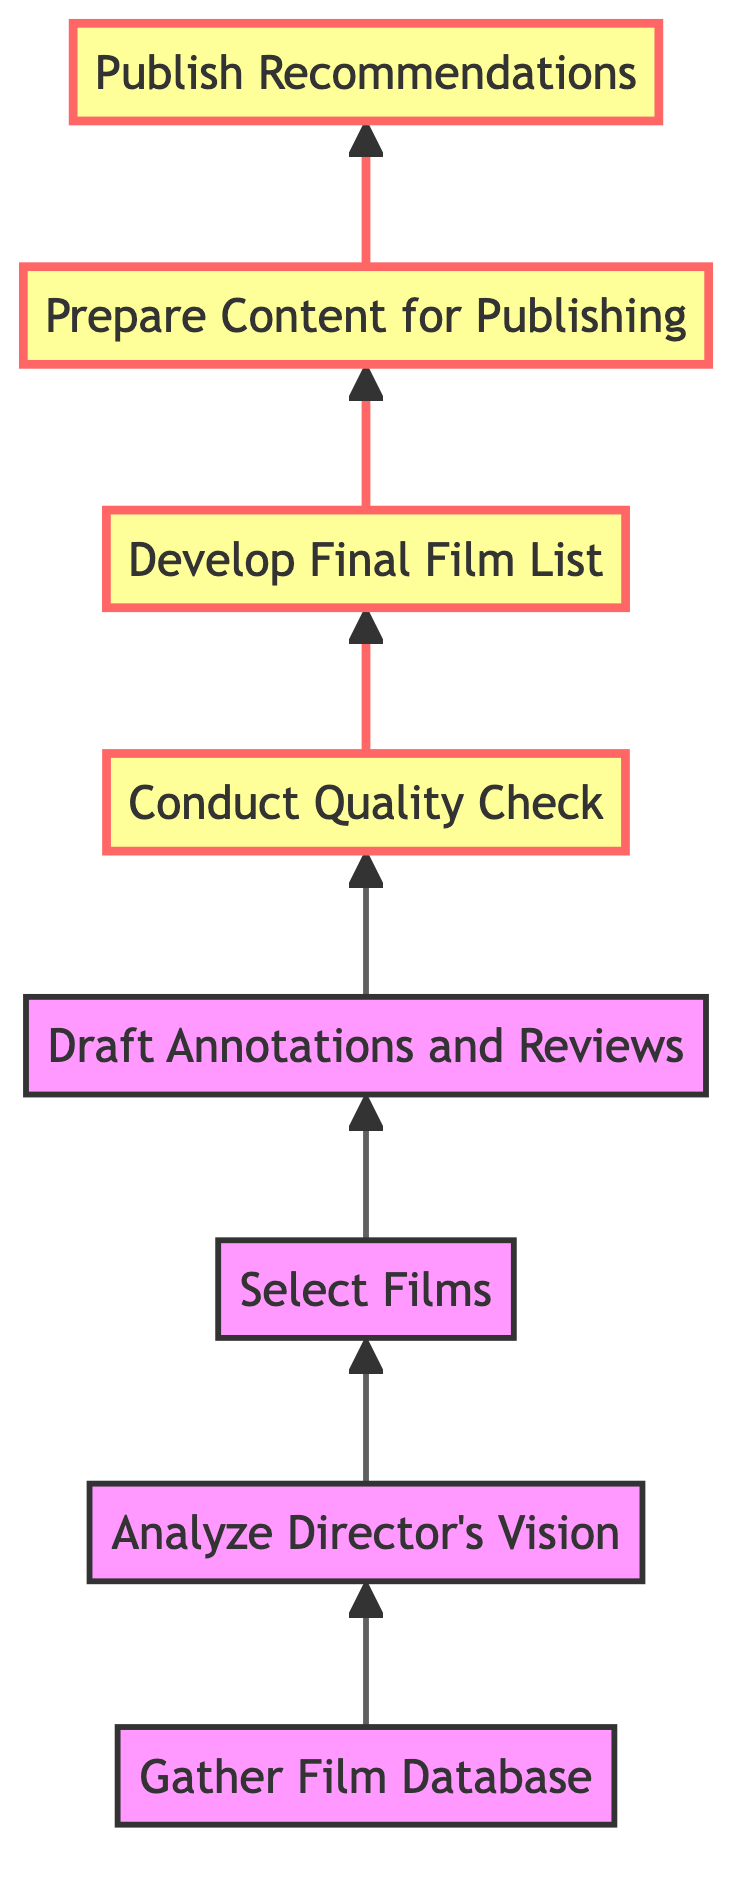What is the first step in the workflow? The first step in the workflow is indicated at the bottom of the diagram. It is "Gather Film Database."
Answer: Gather Film Database How many total steps are in the workflow? By counting the number of unique steps listed in the diagram, there are eight steps total.
Answer: Eight What step follows "Select Films"? Following "Select Films," the next step in the flowchart is "Draft Annotations and Reviews."
Answer: Draft Annotations and Reviews Which step involves reviewing selected films? The step that involves reviewing selected films for accuracy and cohesion is "Conduct Quality Check."
Answer: Conduct Quality Check What is the last step in the workflow? The last step, as indicated at the top of the diagram, is "Publish Recommendations."
Answer: Publish Recommendations Which steps are highlighted in the diagram? In the diagram, the highlighted steps are "Draft Annotations and Reviews," "Conduct Quality Check," "Develop Final Film List," and "Prepare Content for Publishing."
Answer: Draft Annotations and Reviews, Conduct Quality Check, Develop Final Film List, Prepare Content for Publishing Which step is directly dependent on "Analyze Director's Vision"? The step that directly follows "Analyze Director's Vision" and is therefore dependent on it is "Select Films."
Answer: Select Films How many steps are highlighted in total? There are four steps highlighted in the diagram.
Answer: Four What is the relationship between "Develop Final Film List" and "Prepare Content for Publishing"? The relationship is that "Develop Final Film List" leads directly into "Prepare Content for Publishing," indicating a sequential dependency.
Answer: Develop Final Film List leads to Prepare Content for Publishing 